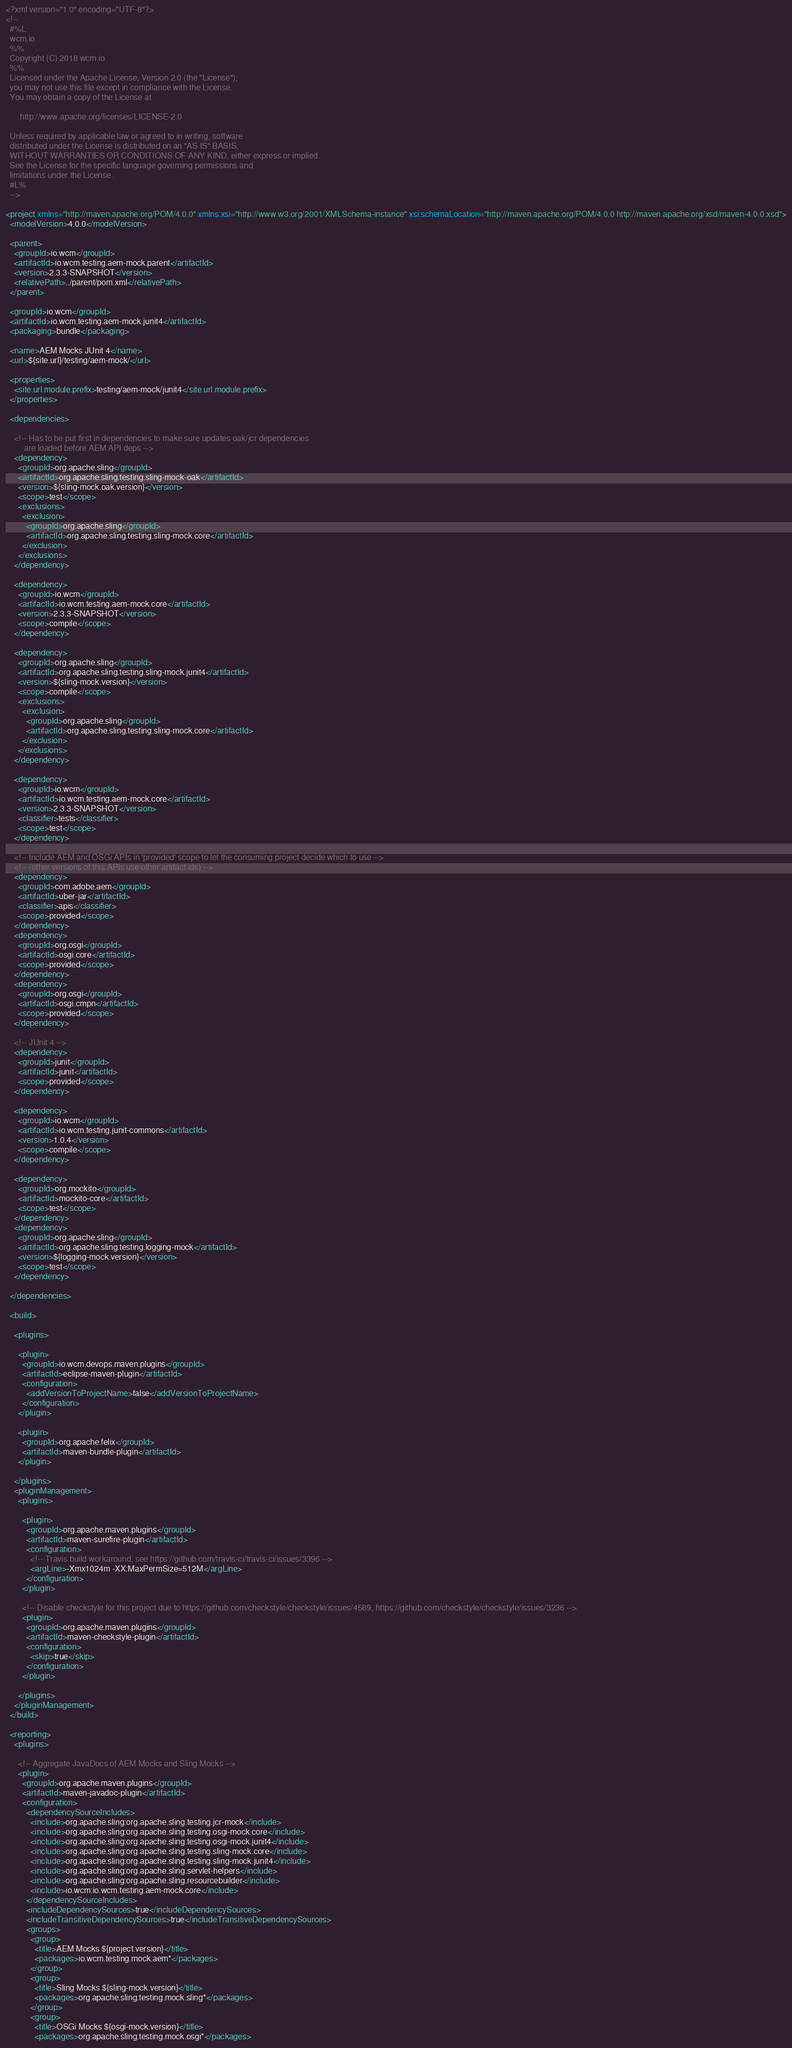Convert code to text. <code><loc_0><loc_0><loc_500><loc_500><_XML_><?xml version="1.0" encoding="UTF-8"?>
<!--
  #%L
  wcm.io
  %%
  Copyright (C) 2018 wcm.io
  %%
  Licensed under the Apache License, Version 2.0 (the "License");
  you may not use this file except in compliance with the License.
  You may obtain a copy of the License at

       http://www.apache.org/licenses/LICENSE-2.0

  Unless required by applicable law or agreed to in writing, software
  distributed under the License is distributed on an "AS IS" BASIS,
  WITHOUT WARRANTIES OR CONDITIONS OF ANY KIND, either express or implied.
  See the License for the specific language governing permissions and
  limitations under the License.
  #L%
  -->

<project xmlns="http://maven.apache.org/POM/4.0.0" xmlns:xsi="http://www.w3.org/2001/XMLSchema-instance" xsi:schemaLocation="http://maven.apache.org/POM/4.0.0 http://maven.apache.org/xsd/maven-4.0.0.xsd">
  <modelVersion>4.0.0</modelVersion>

  <parent>
    <groupId>io.wcm</groupId>
    <artifactId>io.wcm.testing.aem-mock.parent</artifactId>
    <version>2.3.3-SNAPSHOT</version>
    <relativePath>../parent/pom.xml</relativePath>
  </parent>

  <groupId>io.wcm</groupId>
  <artifactId>io.wcm.testing.aem-mock.junit4</artifactId>
  <packaging>bundle</packaging>

  <name>AEM Mocks JUnit 4</name>
  <url>${site.url}/testing/aem-mock/</url>

  <properties>
    <site.url.module.prefix>testing/aem-mock/junit4</site.url.module.prefix>
  </properties>

  <dependencies>

    <!-- Has to be put first in dependencies to make sure updates oak/jcr dependencies
         are loaded before AEM API deps -->
    <dependency>
      <groupId>org.apache.sling</groupId>
      <artifactId>org.apache.sling.testing.sling-mock-oak</artifactId>
      <version>${sling-mock.oak.version}</version>
      <scope>test</scope>
      <exclusions>
        <exclusion>
          <groupId>org.apache.sling</groupId>
          <artifactId>org.apache.sling.testing.sling-mock.core</artifactId>
        </exclusion>
      </exclusions>
    </dependency>

    <dependency>
      <groupId>io.wcm</groupId>
      <artifactId>io.wcm.testing.aem-mock.core</artifactId>
      <version>2.3.3-SNAPSHOT</version>
      <scope>compile</scope>
    </dependency>

    <dependency>
      <groupId>org.apache.sling</groupId>
      <artifactId>org.apache.sling.testing.sling-mock.junit4</artifactId>
      <version>${sling-mock.version}</version>
      <scope>compile</scope>
      <exclusions>
        <exclusion>
          <groupId>org.apache.sling</groupId>
          <artifactId>org.apache.sling.testing.sling-mock.core</artifactId>
        </exclusion>
      </exclusions>
    </dependency>

    <dependency>
      <groupId>io.wcm</groupId>
      <artifactId>io.wcm.testing.aem-mock.core</artifactId>
      <version>2.3.3-SNAPSHOT</version>
      <classifier>tests</classifier>
      <scope>test</scope>
    </dependency>

    <!-- Include AEM and OSGi APIs in 'provided' scope to let the consuming project decide which to use -->
    <!-- (other versions of this APIs use other artifact ids) -->
    <dependency>
      <groupId>com.adobe.aem</groupId>
      <artifactId>uber-jar</artifactId>
      <classifier>apis</classifier>
      <scope>provided</scope>
    </dependency>
    <dependency>
      <groupId>org.osgi</groupId>
      <artifactId>osgi.core</artifactId>
      <scope>provided</scope>
    </dependency>
    <dependency>
      <groupId>org.osgi</groupId>
      <artifactId>osgi.cmpn</artifactId>
      <scope>provided</scope>
    </dependency>

    <!-- JUnit 4 -->
    <dependency>
      <groupId>junit</groupId>
      <artifactId>junit</artifactId>
      <scope>provided</scope>
    </dependency>

    <dependency>
      <groupId>io.wcm</groupId>
      <artifactId>io.wcm.testing.junit-commons</artifactId>
      <version>1.0.4</version>
      <scope>compile</scope>
    </dependency>

    <dependency>
      <groupId>org.mockito</groupId>
      <artifactId>mockito-core</artifactId>
      <scope>test</scope>
    </dependency>
    <dependency>
      <groupId>org.apache.sling</groupId>
      <artifactId>org.apache.sling.testing.logging-mock</artifactId>
      <version>${logging-mock.version}</version>
      <scope>test</scope>
    </dependency>

  </dependencies>

  <build>

    <plugins>

      <plugin>
        <groupId>io.wcm.devops.maven.plugins</groupId>
        <artifactId>eclipse-maven-plugin</artifactId>
        <configuration>
          <addVersionToProjectName>false</addVersionToProjectName>
        </configuration>
      </plugin>

      <plugin>
        <groupId>org.apache.felix</groupId>
        <artifactId>maven-bundle-plugin</artifactId>
      </plugin>

    </plugins>
    <pluginManagement>
      <plugins>

        <plugin>
          <groupId>org.apache.maven.plugins</groupId>
          <artifactId>maven-surefire-plugin</artifactId>
          <configuration>
            <!-- Travis build workaround, see https://github.com/travis-ci/travis-ci/issues/3396 -->
            <argLine>-Xmx1024m -XX:MaxPermSize=512M</argLine>
          </configuration>
        </plugin>

        <!-- Disable checkstyle for this project due to https://github.com/checkstyle/checkstyle/issues/4589, https://github.com/checkstyle/checkstyle/issues/3236 -->
        <plugin>
          <groupId>org.apache.maven.plugins</groupId>
          <artifactId>maven-checkstyle-plugin</artifactId>
          <configuration>
            <skip>true</skip>
          </configuration>
        </plugin>

      </plugins>
    </pluginManagement>
  </build>

  <reporting>
    <plugins>

      <!-- Aggregate JavaDocs of AEM Mocks and Sling Mocks -->
      <plugin>
        <groupId>org.apache.maven.plugins</groupId>
        <artifactId>maven-javadoc-plugin</artifactId>
        <configuration>
          <dependencySourceIncludes>
            <include>org.apache.sling:org.apache.sling.testing.jcr-mock</include>
            <include>org.apache.sling:org.apache.sling.testing.osgi-mock.core</include>
            <include>org.apache.sling:org.apache.sling.testing.osgi-mock.junit4</include>
            <include>org.apache.sling:org.apache.sling.testing.sling-mock.core</include>
            <include>org.apache.sling:org.apache.sling.testing.sling-mock.junit4</include>
            <include>org.apache.sling:org.apache.sling.servlet-helpers</include>
            <include>org.apache.sling:org.apache.sling.resourcebuilder</include>
            <include>io.wcm:io.wcm.testing.aem-mock.core</include>
          </dependencySourceIncludes>
          <includeDependencySources>true</includeDependencySources>
          <includeTransitiveDependencySources>true</includeTransitiveDependencySources>
          <groups>
            <group>
              <title>AEM Mocks ${project.version}</title>
              <packages>io.wcm.testing.mock.aem*</packages>
            </group>
            <group>
              <title>Sling Mocks ${sling-mock.version}</title>
              <packages>org.apache.sling.testing.mock.sling*</packages>
            </group>
            <group>
              <title>OSGi Mocks ${osgi-mock.version}</title>
              <packages>org.apache.sling.testing.mock.osgi*</packages></code> 